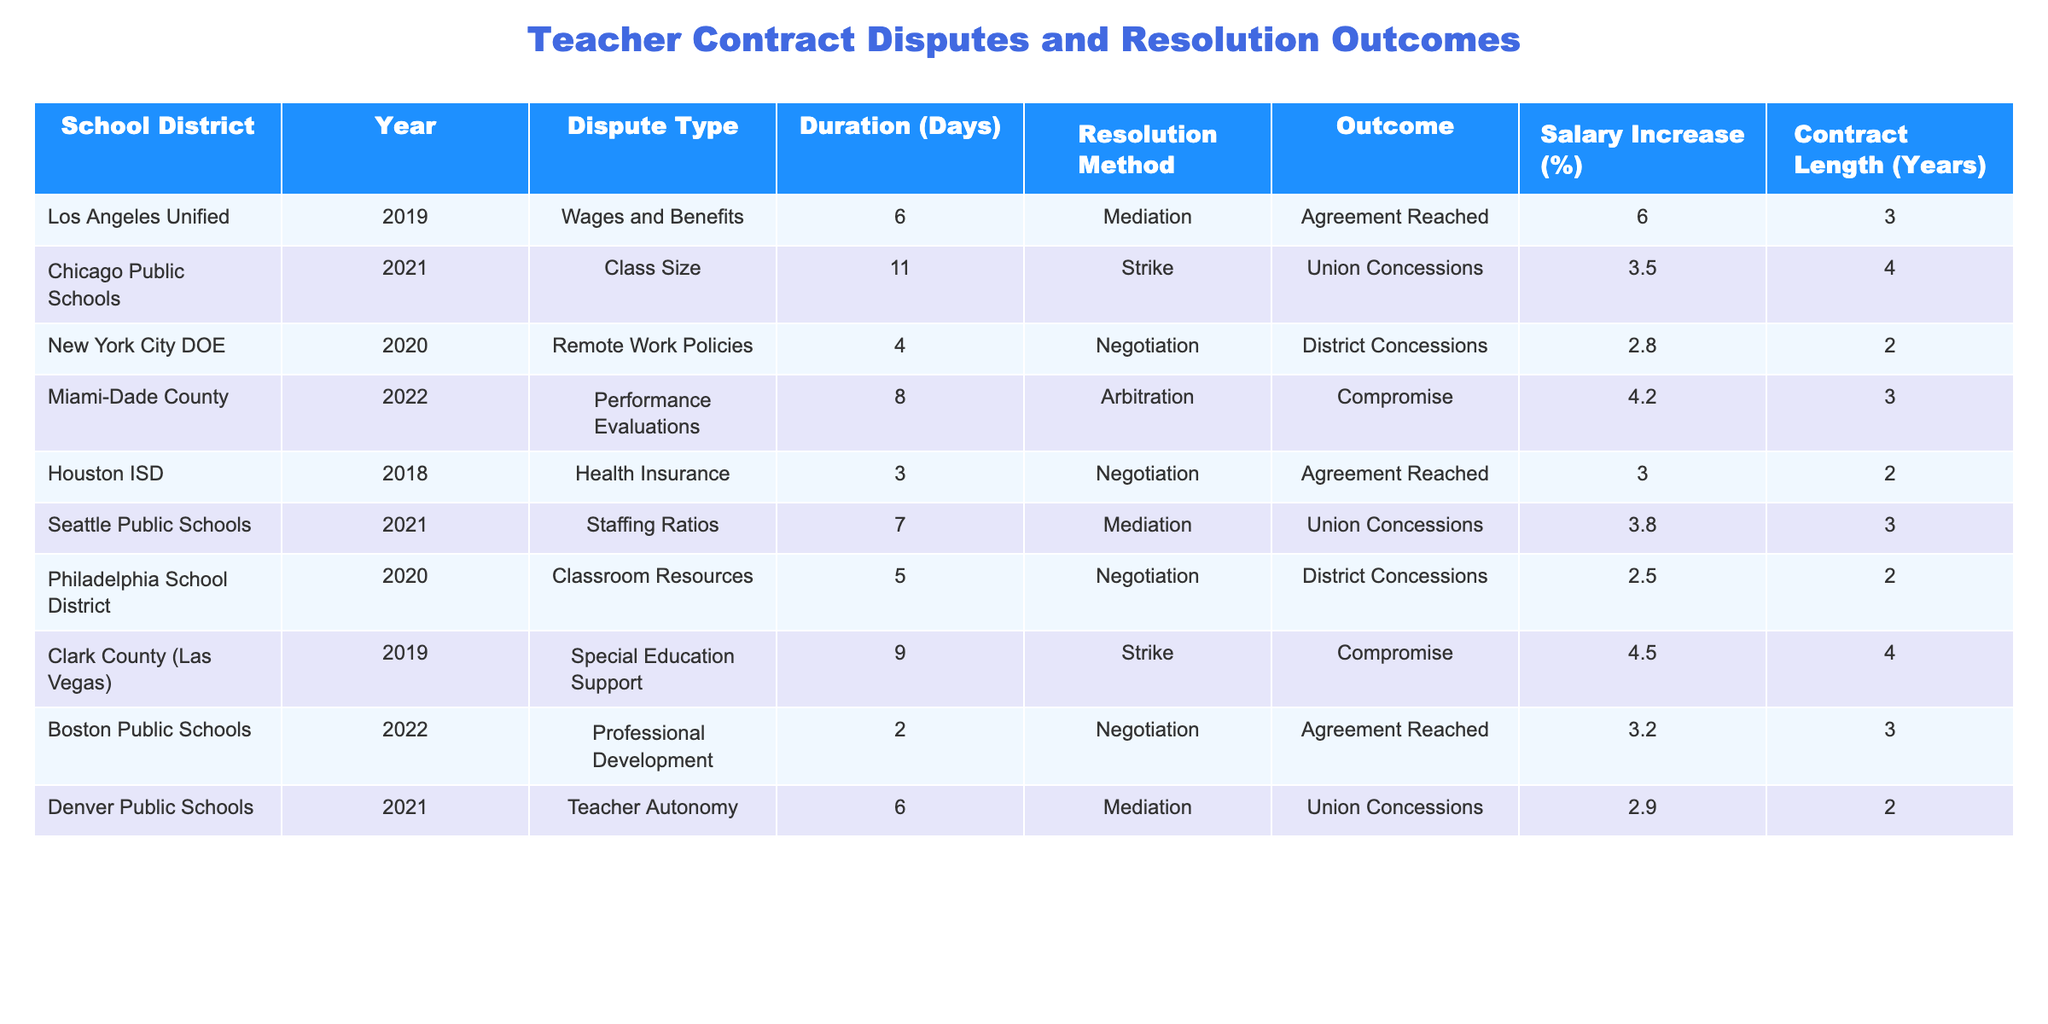What is the longest duration of a dispute listed in the table? The longest duration is found by checking the "Duration (Days)" column, where the maximum value is 11 days for the Chicago Public Schools dispute.
Answer: 11 Which resolution method was used most frequently? By counting the occurrences of each resolution method in the "Resolution Method" column, mediation appears 5 times, more than any other method.
Answer: Mediation Did any disputes result in a "Compromise"? Looking through the "Outcome" column, I can see that there are two disputes that reached a "Compromise": the Miami-Dade County and Clark County disputes.
Answer: Yes What is the average salary increase percentage from these disputes? To find the average, sum all salary increases (6.0 + 3.5 + 2.8 + 4.2 + 3.0 + 3.8 + 2.5 + 4.5 + 3.2 + 2.9 = 36.4) and divide by the number of disputes (10), resulting in an average of 3.64%.
Answer: 3.64 Which school district had the shortest dispute duration, and how many days did it last? By comparing the durations in the table, I see that the shortest was 2 days, which corresponds to the Boston Public Schools dispute.
Answer: Boston Public Schools; 2 days What percentage of disputes resulted in an "Agreement Reached"? To find this percentage, count the number of disputes with "Agreement Reached" (3 out of 10 total), then calculate (3/10) * 100 = 30%.
Answer: 30% In how many cases did the union make concessions, and what was the average salary increase in those cases? The disputes with union concessions (Chicago Public Schools, Seattle Public Schools, Denver Public Schools) total 3, with salary increases of 3.5%, 3.8%, and 2.9%. Their average is (3.5 + 3.8 + 2.9) / 3 = 3.4%.
Answer: 3 cases; 3.4% What is the most common dispute type associated with agreements? Several rows show an agreement outcome, and the most frequent dispute type in those rows is "Wages and Benefits," which appears once as an agreement case.
Answer: Wages and Benefits How many disputes with a duration less than 5 days resulted in union concessions? Inspecting the "Duration (Days)" column, only the New York City DOE (4 days) and the Boston Public Schools (2 days) fall under 5 days, but neither resulted in union concessions.
Answer: 0 disputes What is the difference in salary increase percentages between the highest and lowest outcomes? The highest is 6.0% (Los Angeles Unified), and the lowest is 2.5% (Philadelphia School District). The difference is 6.0% - 2.5% = 3.5%.
Answer: 3.5% 